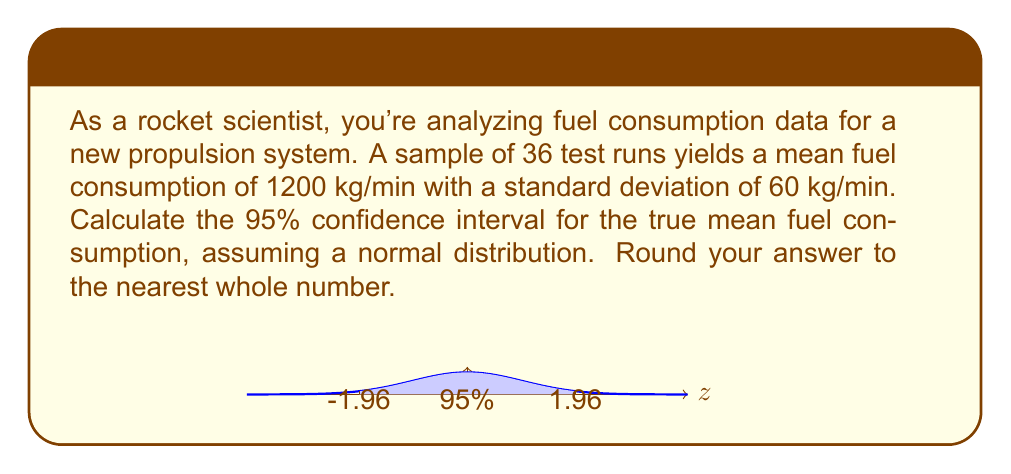Help me with this question. To calculate the confidence interval, we'll use the formula:

$$ \text{CI} = \bar{x} \pm z_{\alpha/2} \cdot \frac{\sigma}{\sqrt{n}} $$

Where:
- $\bar{x}$ is the sample mean (1200 kg/min)
- $z_{\alpha/2}$ is the z-score for a 95% confidence level (1.96)
- $\sigma$ is the standard deviation (60 kg/min)
- $n$ is the sample size (36)

Steps:
1) Calculate the standard error: 
   $$ SE = \frac{\sigma}{\sqrt{n}} = \frac{60}{\sqrt{36}} = 10 $$

2) Calculate the margin of error:
   $$ ME = z_{\alpha/2} \cdot SE = 1.96 \cdot 10 = 19.6 $$

3) Calculate the confidence interval:
   $$ \text{CI} = 1200 \pm 19.6 $$
   $$ \text{CI} = [1180.4, 1219.6] $$

4) Round to the nearest whole number:
   $$ \text{CI} = [1180, 1220] $$

Therefore, we can say with 95% confidence that the true mean fuel consumption lies between 1180 kg/min and 1220 kg/min.
Answer: [1180, 1220] kg/min 